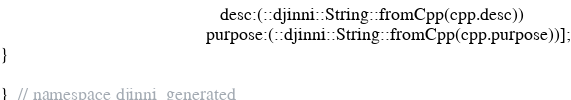<code> <loc_0><loc_0><loc_500><loc_500><_ObjectiveC_>                                               desc:(::djinni::String::fromCpp(cpp.desc))
                                            purpose:(::djinni::String::fromCpp(cpp.purpose))];
}

}  // namespace djinni_generated
</code> 